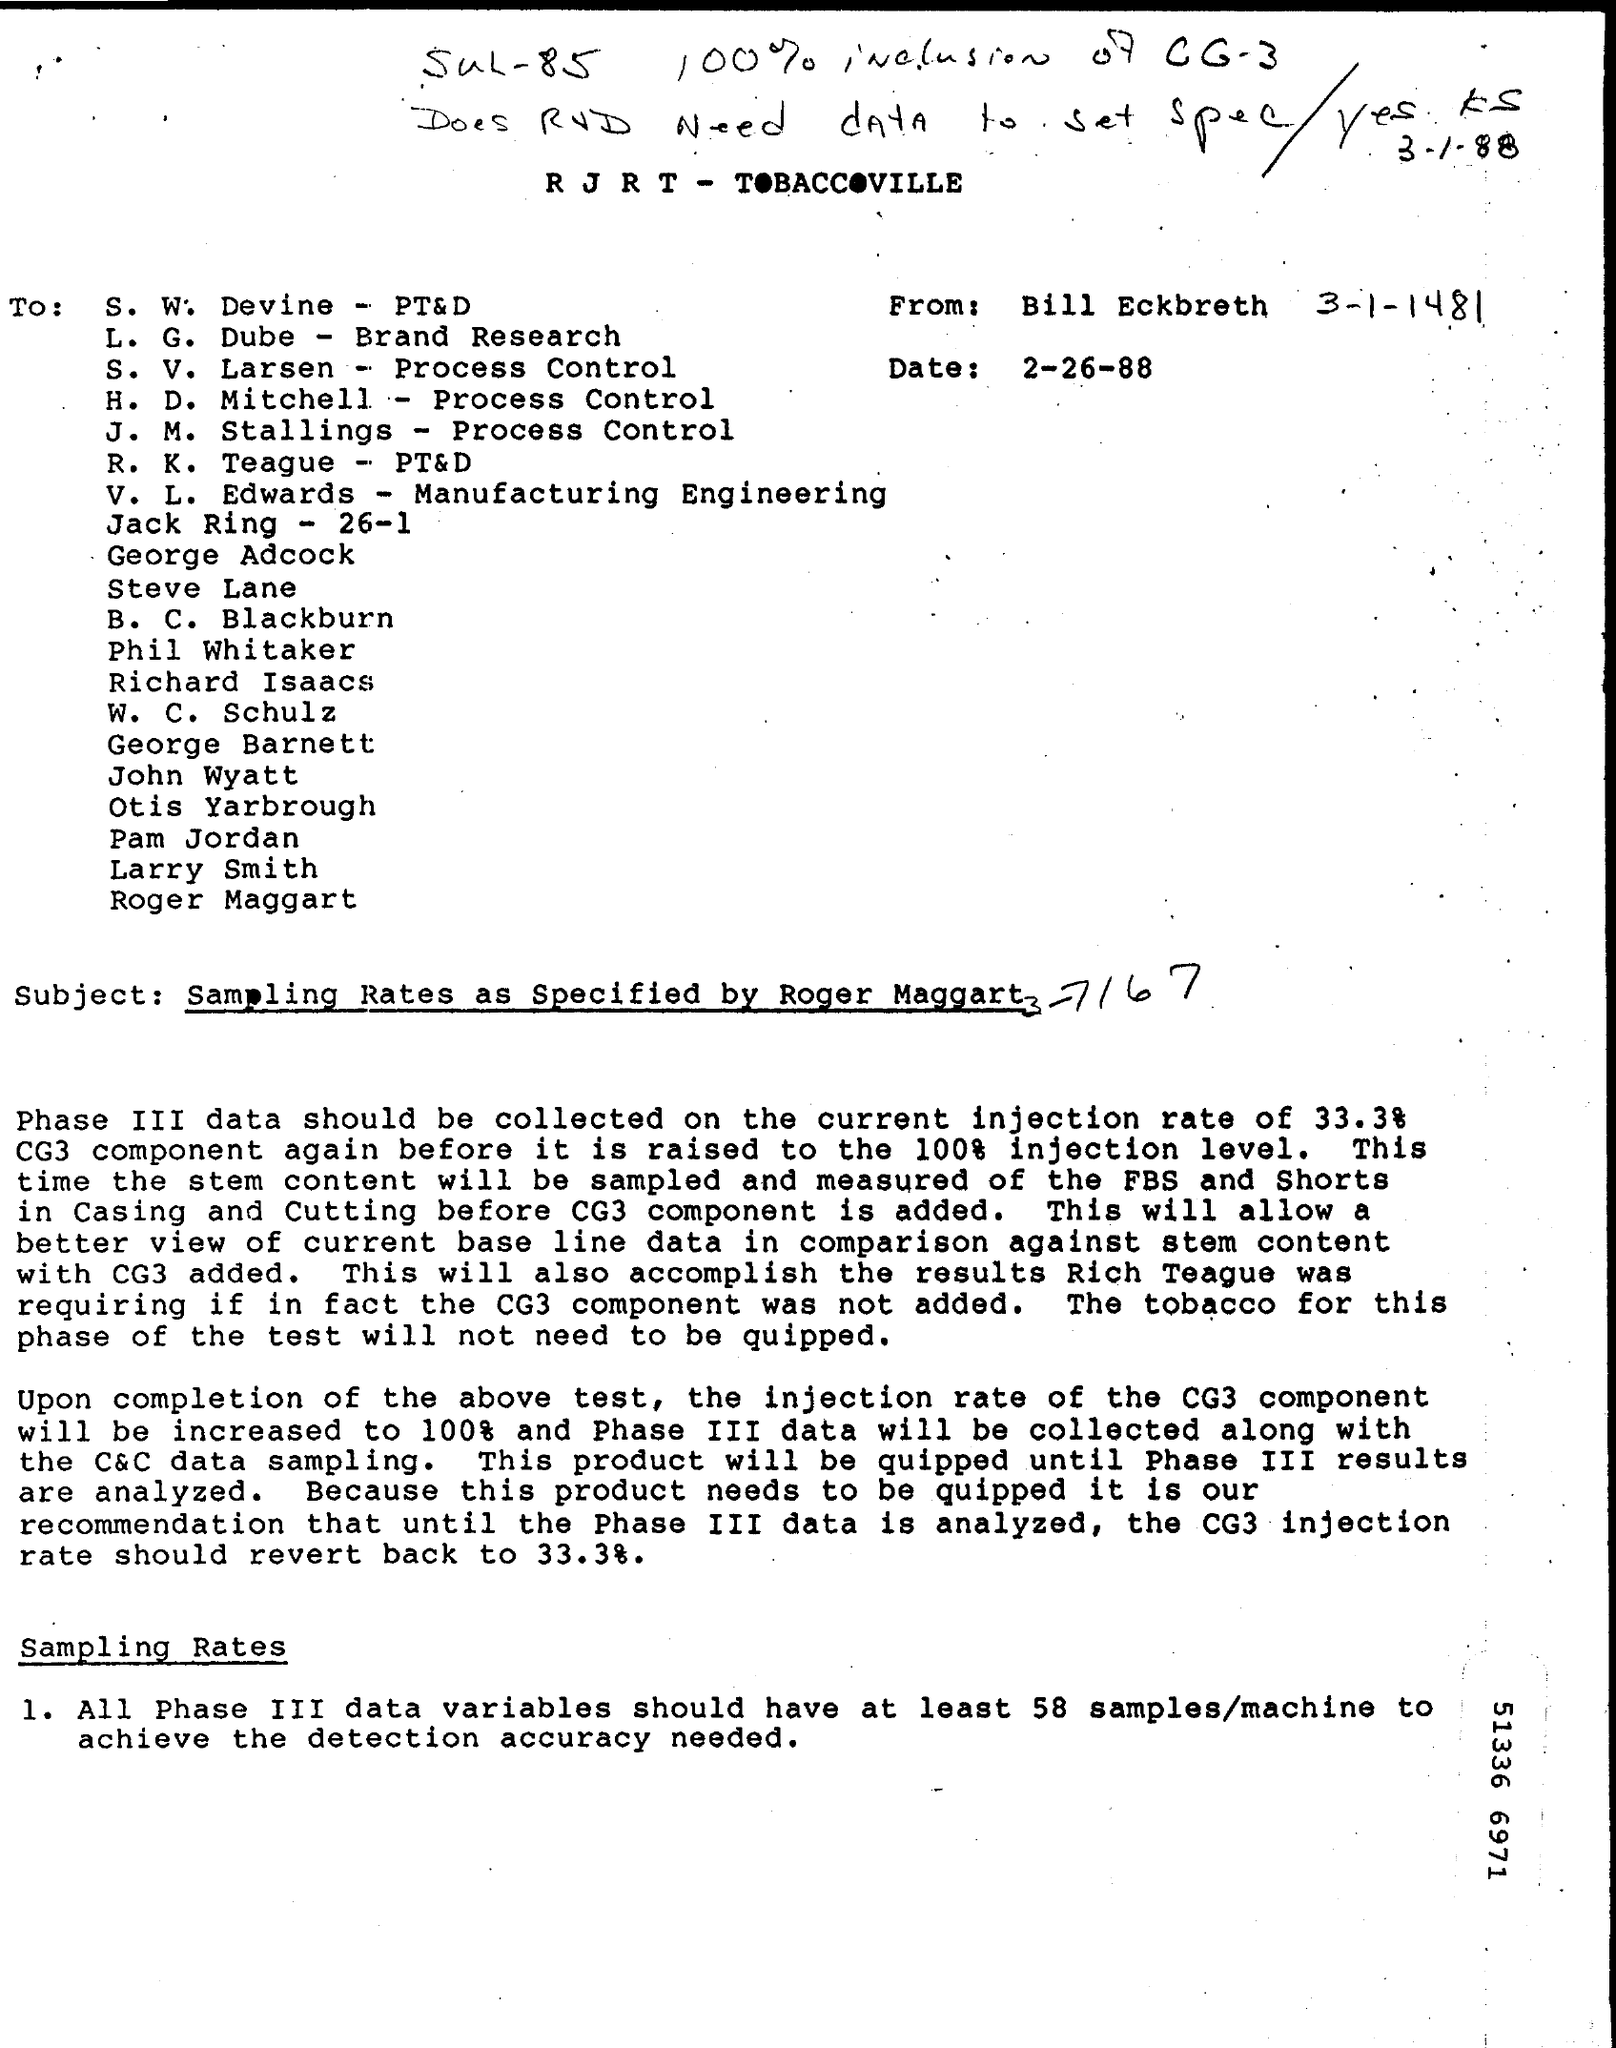Give some essential details in this illustration. The document is dated February 26, 1988. The subject of the document is sampling rates, as specified by Roger Maggart. 